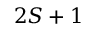<formula> <loc_0><loc_0><loc_500><loc_500>2 S + 1</formula> 